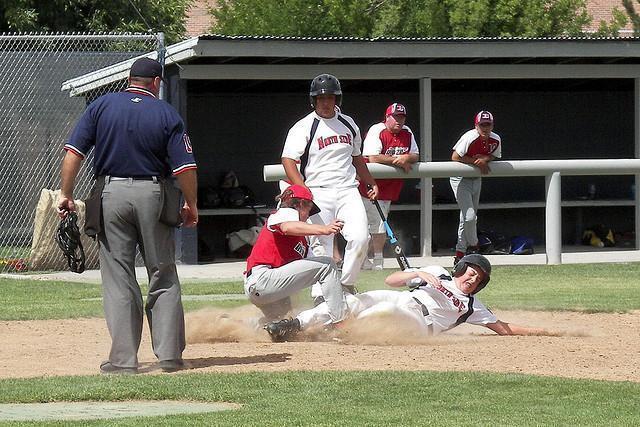Who famously helped win a 1992 playoff game doing what the boy in the black helmet is doing?
Make your selection from the four choices given to correctly answer the question.
Options: Jacob degrom, manny acta, pete schourek, sid bream. Sid bream. 